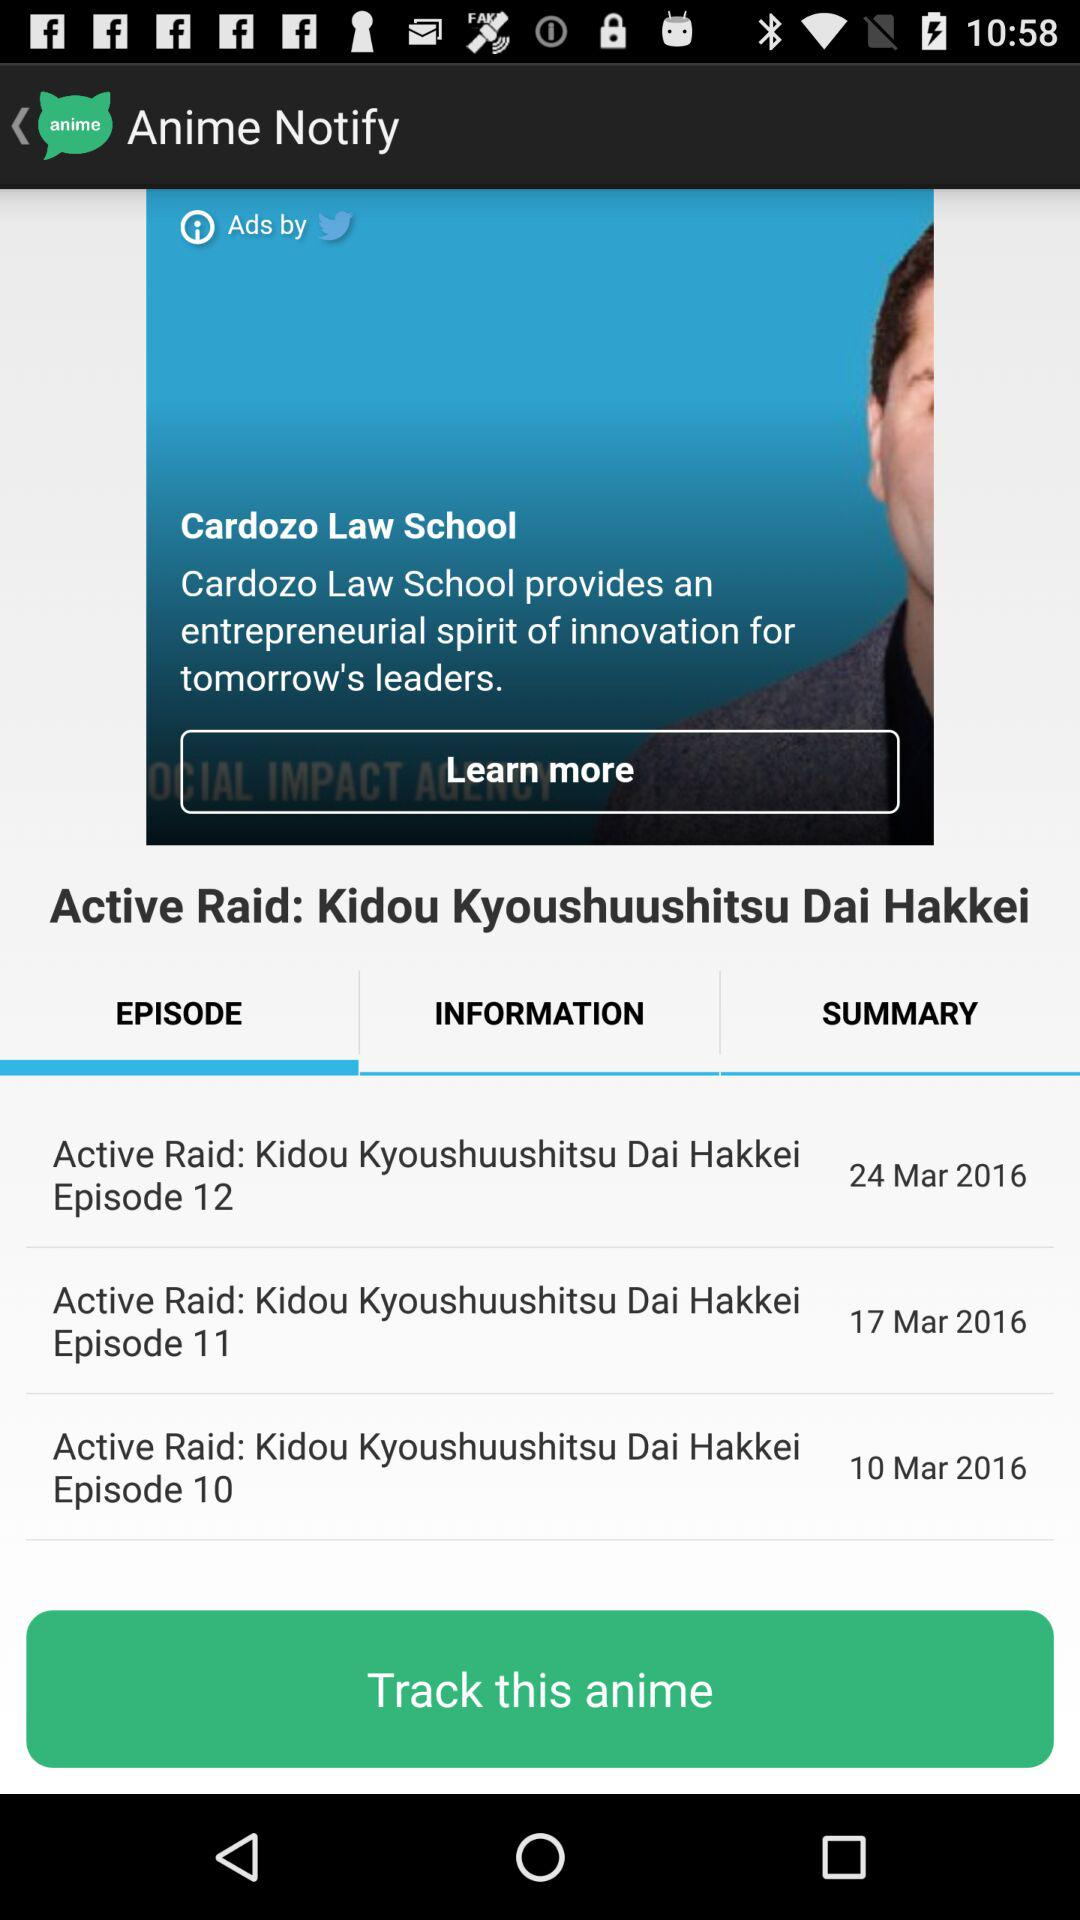What is the name of the application? The application name is "Anime Notify". 